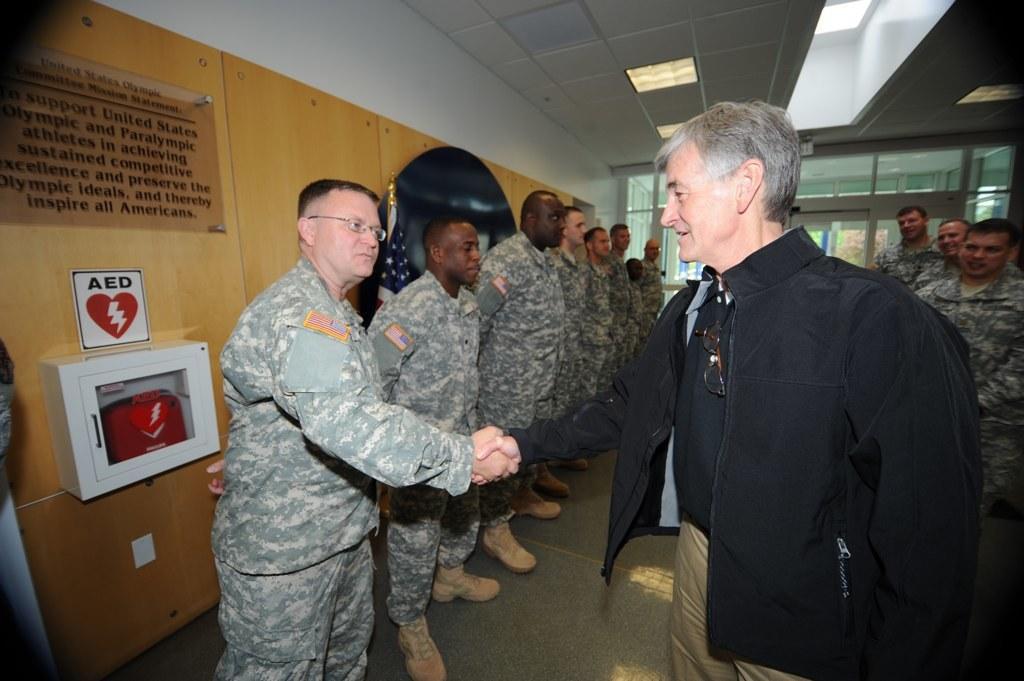Could you give a brief overview of what you see in this image? In this image in the front there are persons standing and shaking hands with each other. In the background there are persons standing. On the left side there is a flag and there are boards with some text written on it and there is an object which is white in colour, in the object there is a bag which is red in colour and there are windows and there is a door in the background. At the top there are lights. 